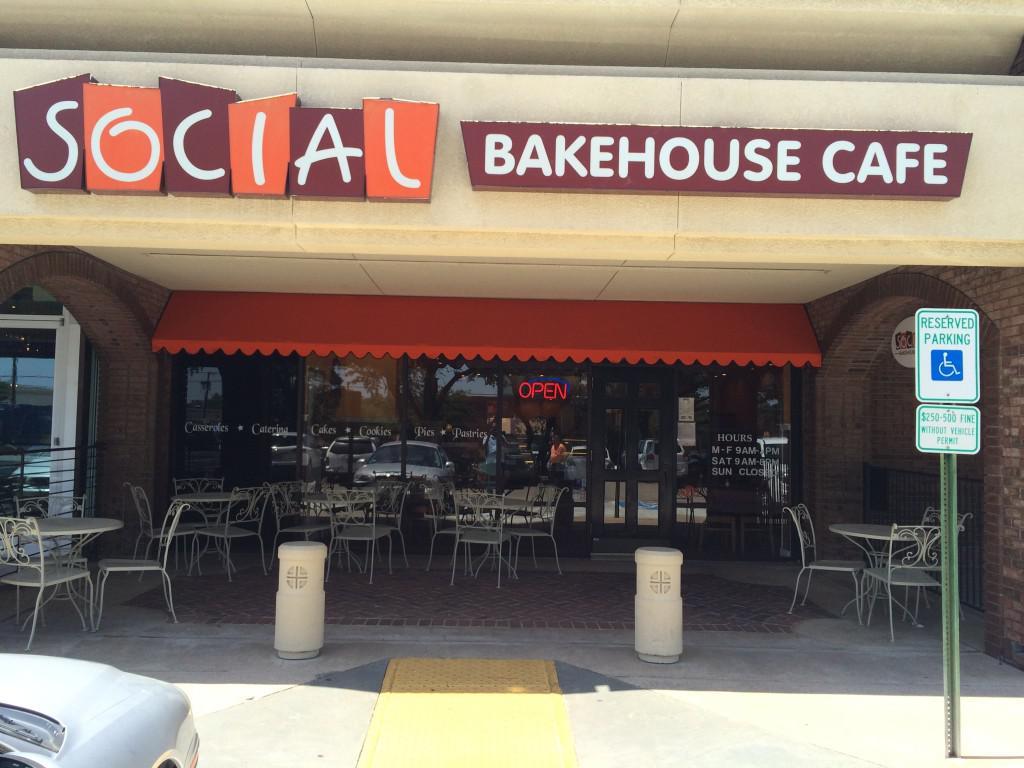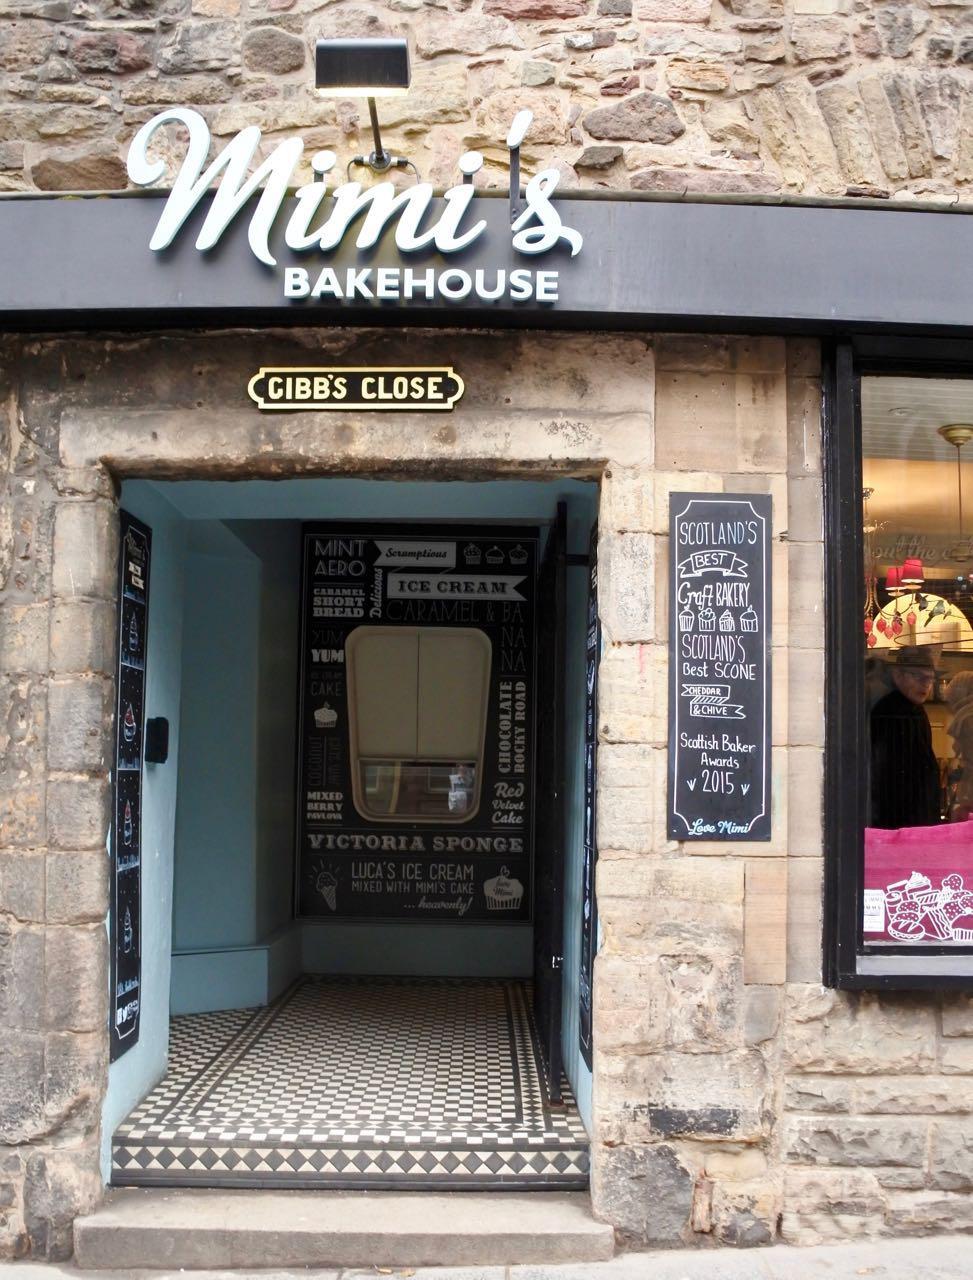The first image is the image on the left, the second image is the image on the right. For the images shown, is this caption "A single person is outside of the shop in one of the images." true? Answer yes or no. No. 